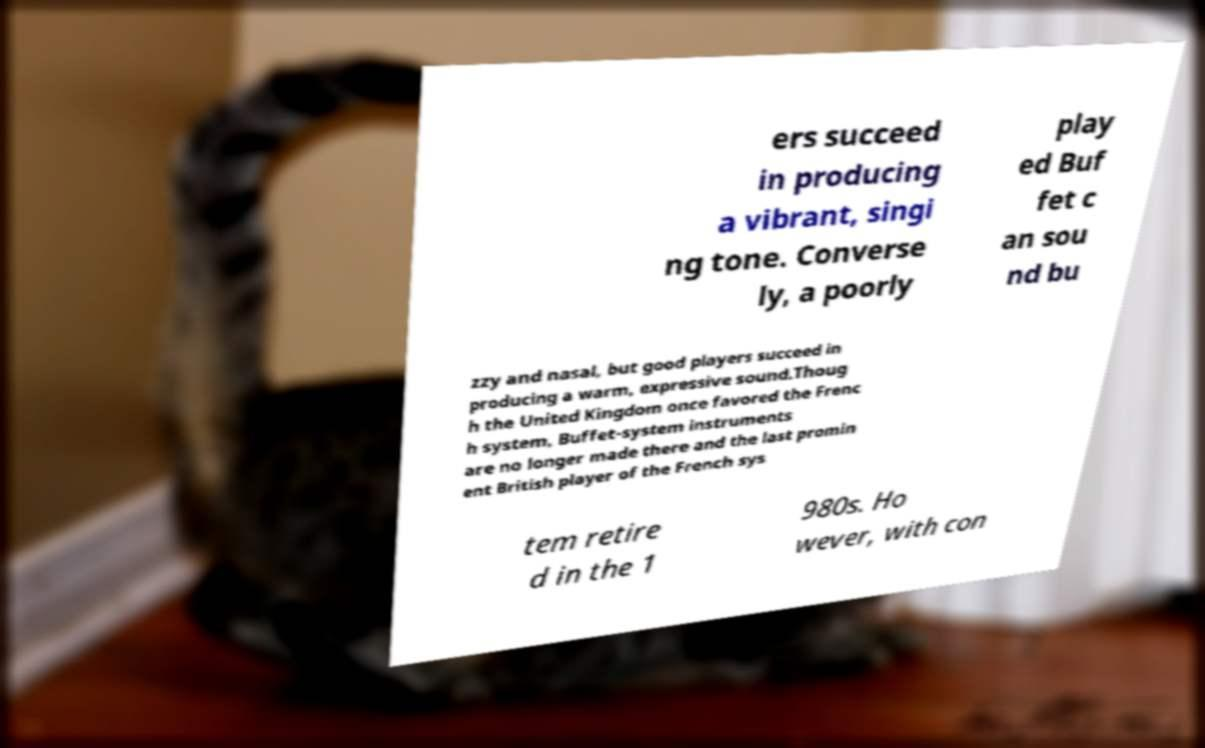Please identify and transcribe the text found in this image. ers succeed in producing a vibrant, singi ng tone. Converse ly, a poorly play ed Buf fet c an sou nd bu zzy and nasal, but good players succeed in producing a warm, expressive sound.Thoug h the United Kingdom once favored the Frenc h system, Buffet-system instruments are no longer made there and the last promin ent British player of the French sys tem retire d in the 1 980s. Ho wever, with con 